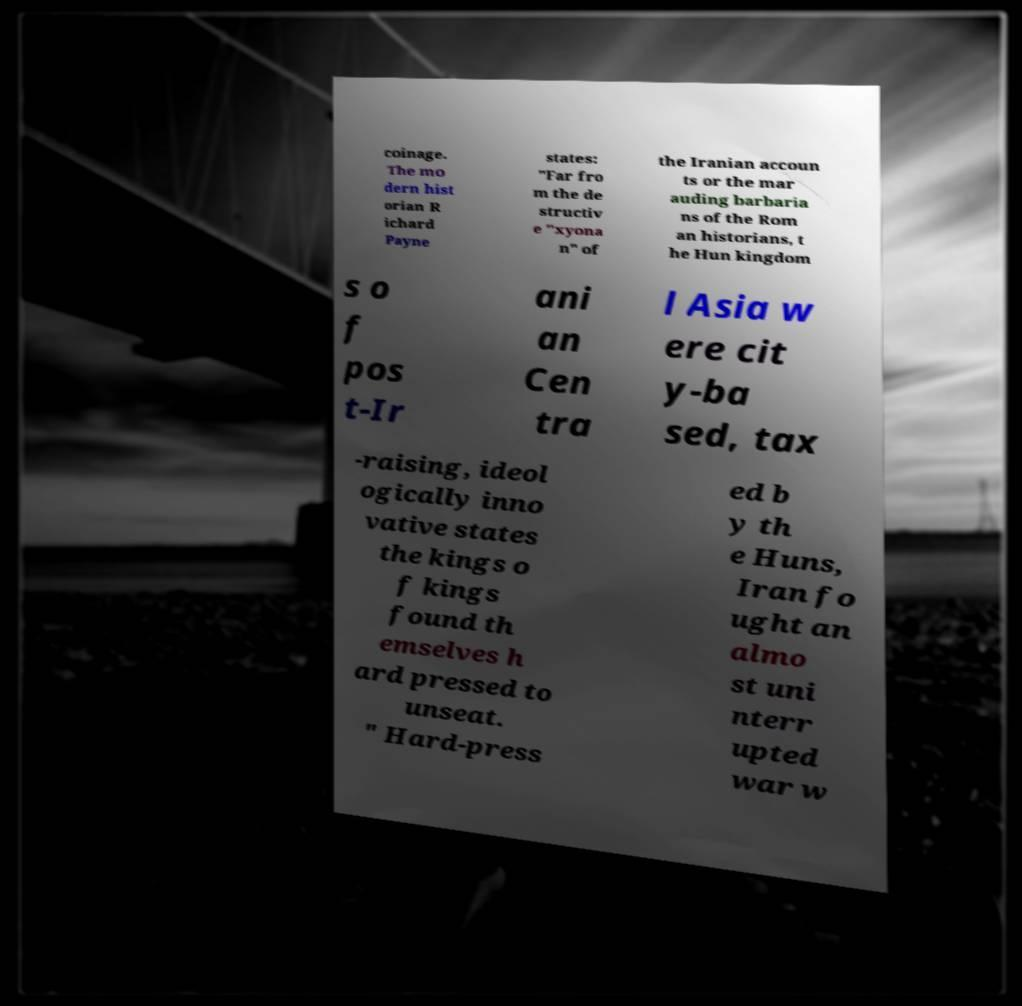Can you accurately transcribe the text from the provided image for me? coinage. The mo dern hist orian R ichard Payne states: "Far fro m the de structiv e "xyona n" of the Iranian accoun ts or the mar auding barbaria ns of the Rom an historians, t he Hun kingdom s o f pos t-Ir ani an Cen tra l Asia w ere cit y-ba sed, tax -raising, ideol ogically inno vative states the kings o f kings found th emselves h ard pressed to unseat. " Hard-press ed b y th e Huns, Iran fo ught an almo st uni nterr upted war w 